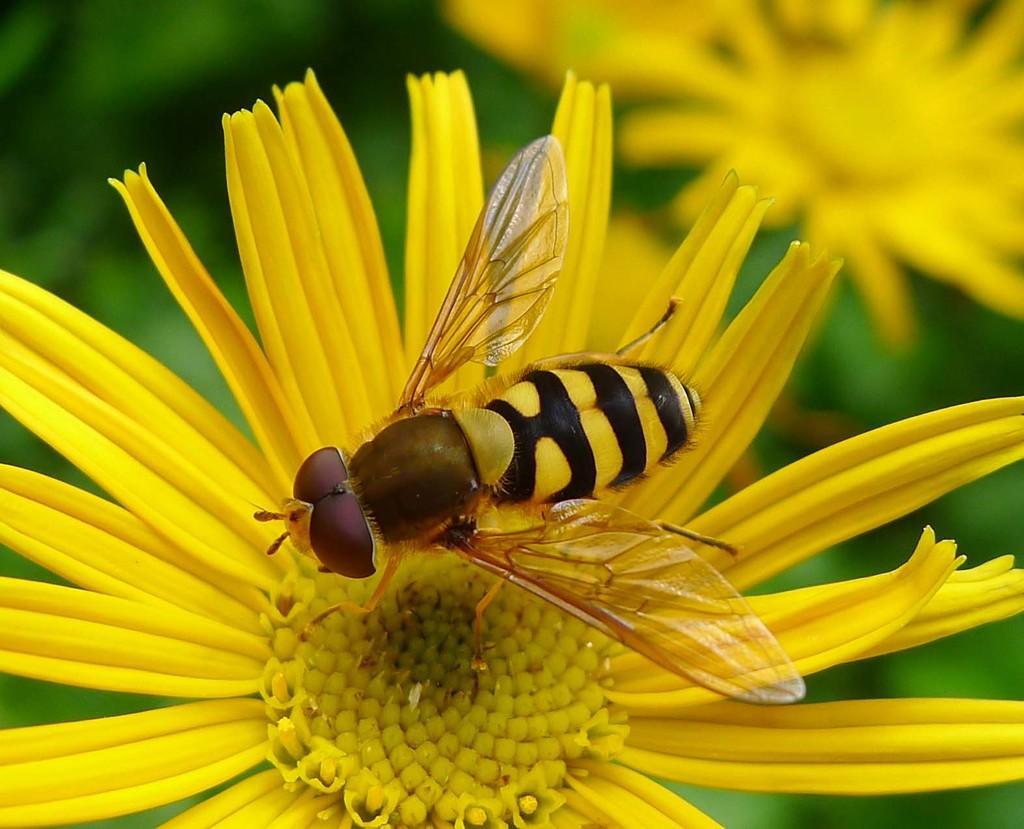Describe this image in one or two sentences. In this image in the foreground there is one bee on a flower, and there are some flowers and there is blurry background. 